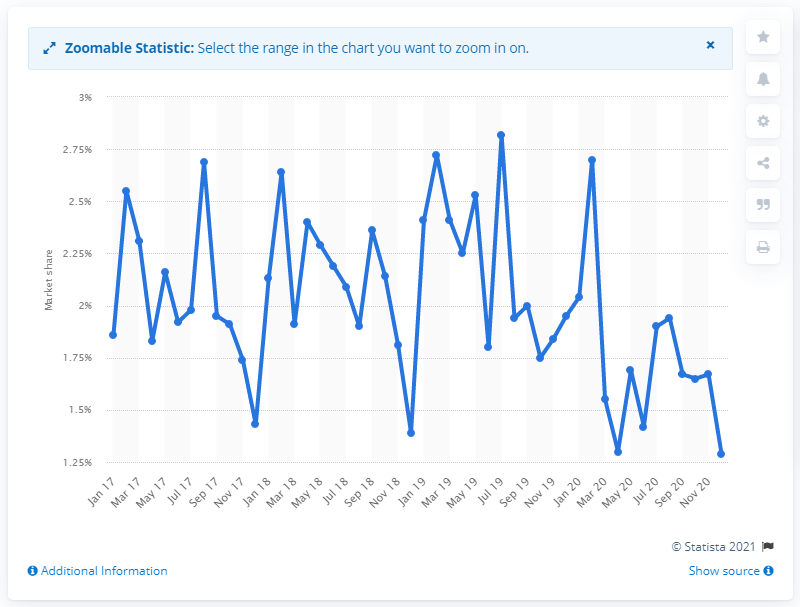List a handful of essential elements in this visual. In December 2020, the market share of Citroen was 1.29%. During the period of January 2017 to December 2020, the monthly market share of Citroen in the UK was 2.64%. 